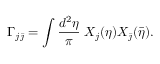<formula> <loc_0><loc_0><loc_500><loc_500>\Gamma _ { j \bar { \jmath } } = \int \frac { d ^ { 2 } \eta } { \pi } \, X _ { j } ( \eta ) X _ { \bar { \jmath } } ( \bar { \eta } ) .</formula> 